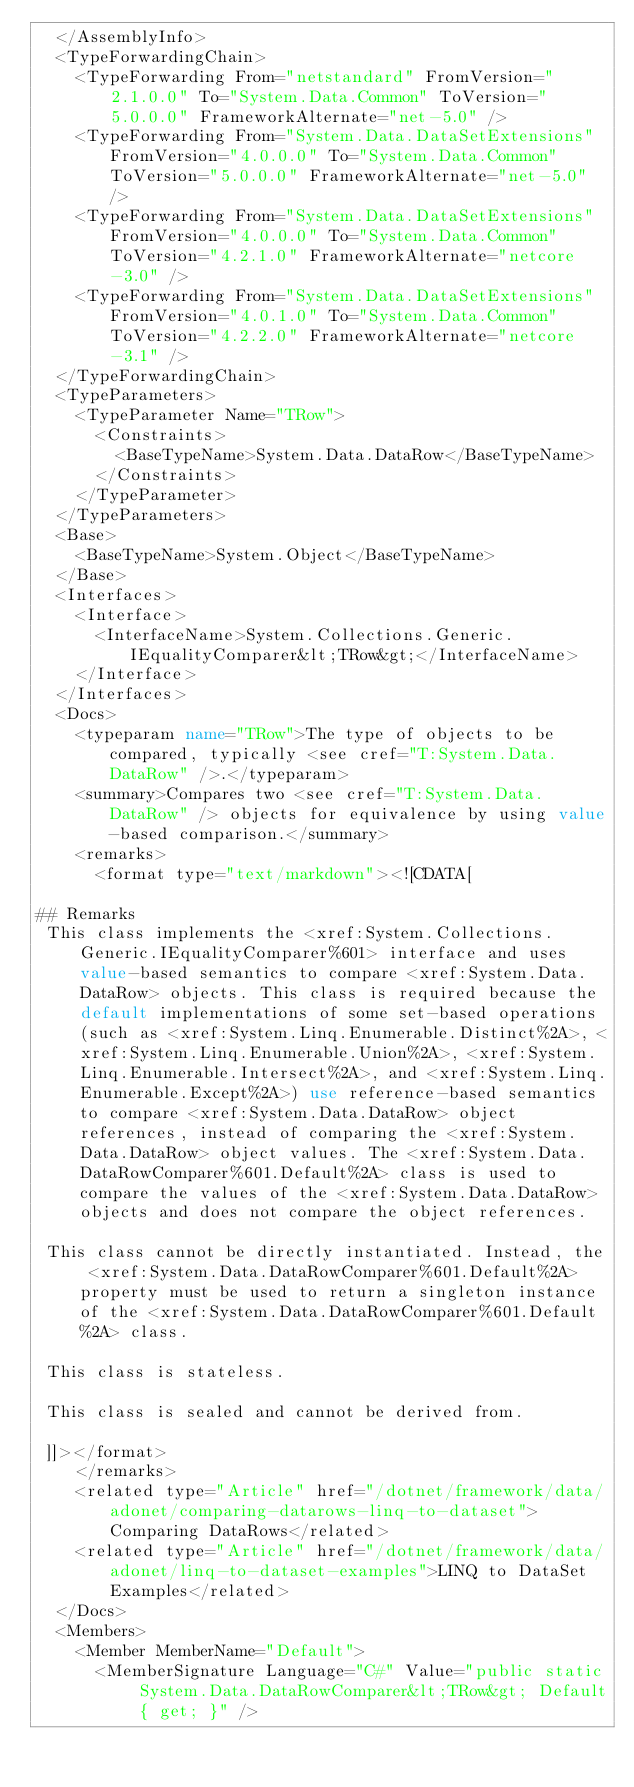Convert code to text. <code><loc_0><loc_0><loc_500><loc_500><_XML_>  </AssemblyInfo>
  <TypeForwardingChain>
    <TypeForwarding From="netstandard" FromVersion="2.1.0.0" To="System.Data.Common" ToVersion="5.0.0.0" FrameworkAlternate="net-5.0" />
    <TypeForwarding From="System.Data.DataSetExtensions" FromVersion="4.0.0.0" To="System.Data.Common" ToVersion="5.0.0.0" FrameworkAlternate="net-5.0" />
    <TypeForwarding From="System.Data.DataSetExtensions" FromVersion="4.0.0.0" To="System.Data.Common" ToVersion="4.2.1.0" FrameworkAlternate="netcore-3.0" />
    <TypeForwarding From="System.Data.DataSetExtensions" FromVersion="4.0.1.0" To="System.Data.Common" ToVersion="4.2.2.0" FrameworkAlternate="netcore-3.1" />
  </TypeForwardingChain>
  <TypeParameters>
    <TypeParameter Name="TRow">
      <Constraints>
        <BaseTypeName>System.Data.DataRow</BaseTypeName>
      </Constraints>
    </TypeParameter>
  </TypeParameters>
  <Base>
    <BaseTypeName>System.Object</BaseTypeName>
  </Base>
  <Interfaces>
    <Interface>
      <InterfaceName>System.Collections.Generic.IEqualityComparer&lt;TRow&gt;</InterfaceName>
    </Interface>
  </Interfaces>
  <Docs>
    <typeparam name="TRow">The type of objects to be compared, typically <see cref="T:System.Data.DataRow" />.</typeparam>
    <summary>Compares two <see cref="T:System.Data.DataRow" /> objects for equivalence by using value-based comparison.</summary>
    <remarks>
      <format type="text/markdown"><![CDATA[  
  
## Remarks  
 This class implements the <xref:System.Collections.Generic.IEqualityComparer%601> interface and uses value-based semantics to compare <xref:System.Data.DataRow> objects. This class is required because the default implementations of some set-based operations (such as <xref:System.Linq.Enumerable.Distinct%2A>, <xref:System.Linq.Enumerable.Union%2A>, <xref:System.Linq.Enumerable.Intersect%2A>, and <xref:System.Linq.Enumerable.Except%2A>) use reference-based semantics to compare <xref:System.Data.DataRow> object references, instead of comparing the <xref:System.Data.DataRow> object values. The <xref:System.Data.DataRowComparer%601.Default%2A> class is used to compare the values of the <xref:System.Data.DataRow> objects and does not compare the object references.  
  
 This class cannot be directly instantiated. Instead, the <xref:System.Data.DataRowComparer%601.Default%2A> property must be used to return a singleton instance of the <xref:System.Data.DataRowComparer%601.Default%2A> class.  
  
 This class is stateless.  
  
 This class is sealed and cannot be derived from.  
  
 ]]></format>
    </remarks>
    <related type="Article" href="/dotnet/framework/data/adonet/comparing-datarows-linq-to-dataset">Comparing DataRows</related>
    <related type="Article" href="/dotnet/framework/data/adonet/linq-to-dataset-examples">LINQ to DataSet Examples</related>
  </Docs>
  <Members>
    <Member MemberName="Default">
      <MemberSignature Language="C#" Value="public static System.Data.DataRowComparer&lt;TRow&gt; Default { get; }" /></code> 